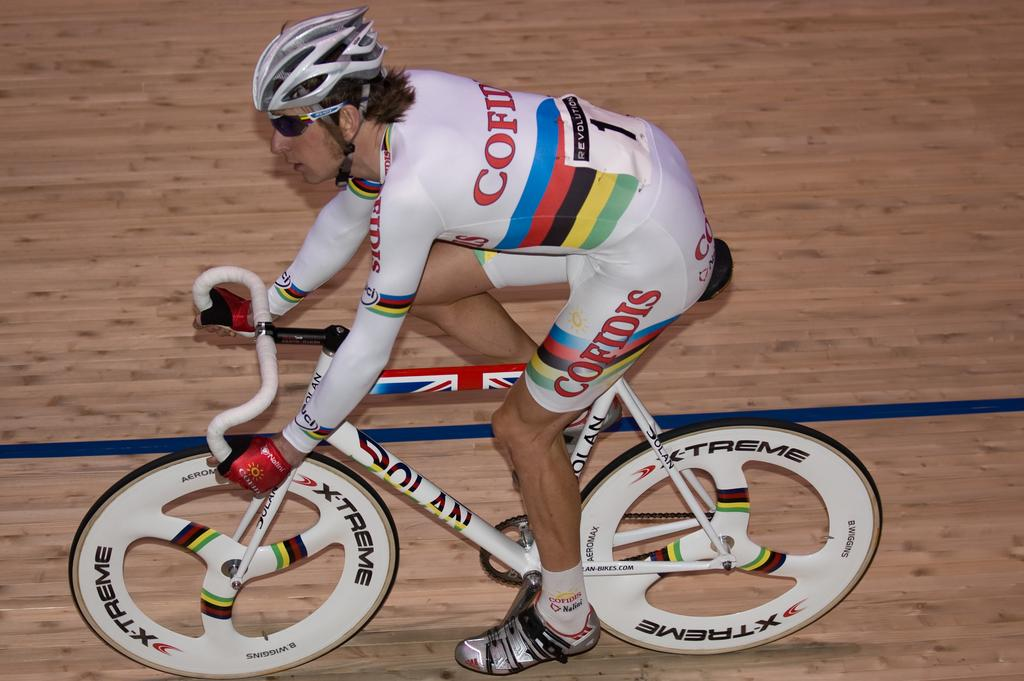Who is the main subject in the image? There is a man in the image. What is the man doing in the image? The man is riding a bicycle. What surface is the man riding the bicycle on? There is a floor visible in the image. How many frogs can be seen on the man's toes in the image? There are no frogs present on the man's toes in the image. 